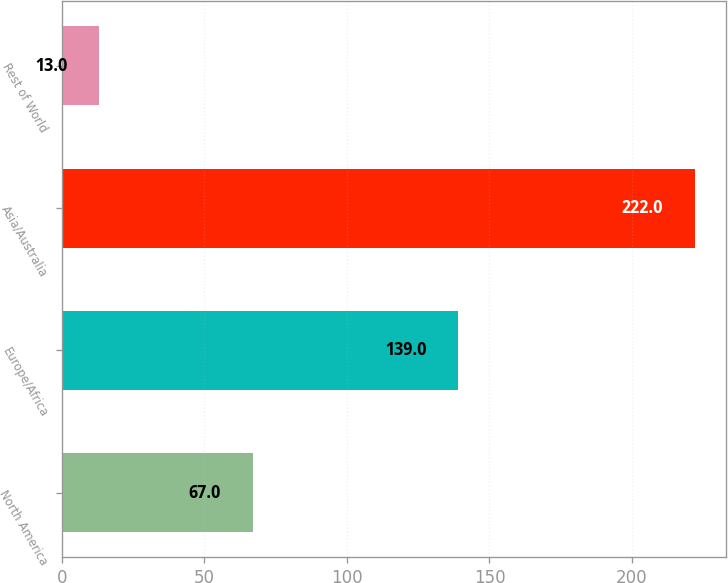Convert chart to OTSL. <chart><loc_0><loc_0><loc_500><loc_500><bar_chart><fcel>North America<fcel>Europe/Africa<fcel>Asia/Australia<fcel>Rest of World<nl><fcel>67<fcel>139<fcel>222<fcel>13<nl></chart> 